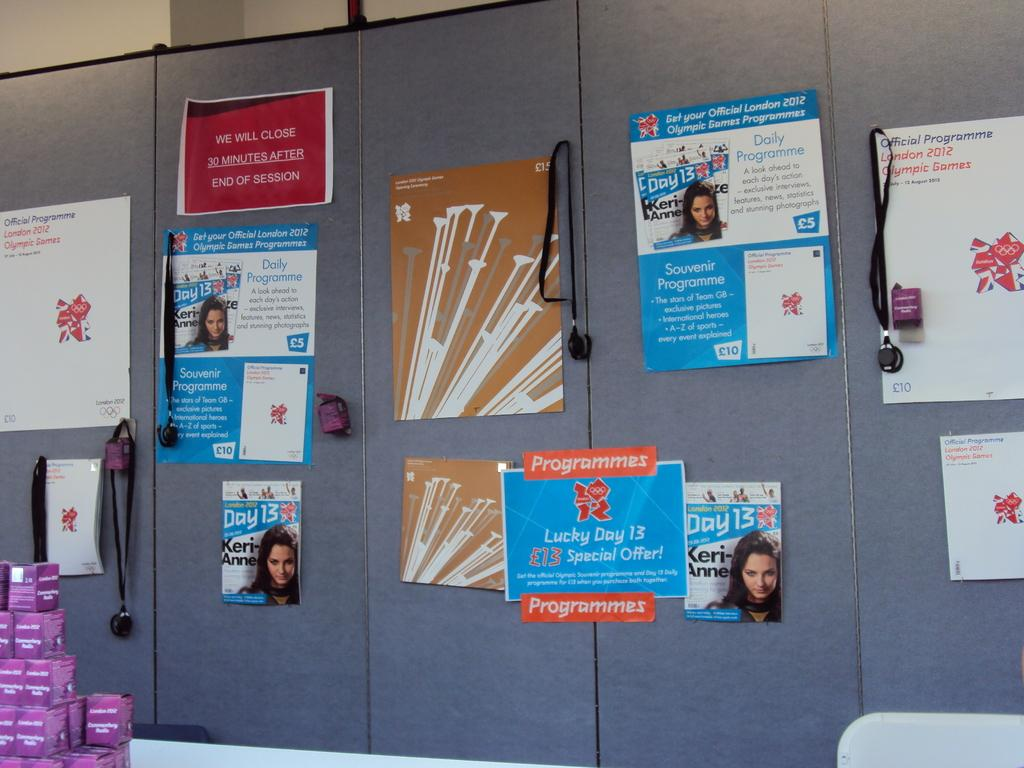<image>
Relay a brief, clear account of the picture shown. many posters for day 13 programmes special offer 